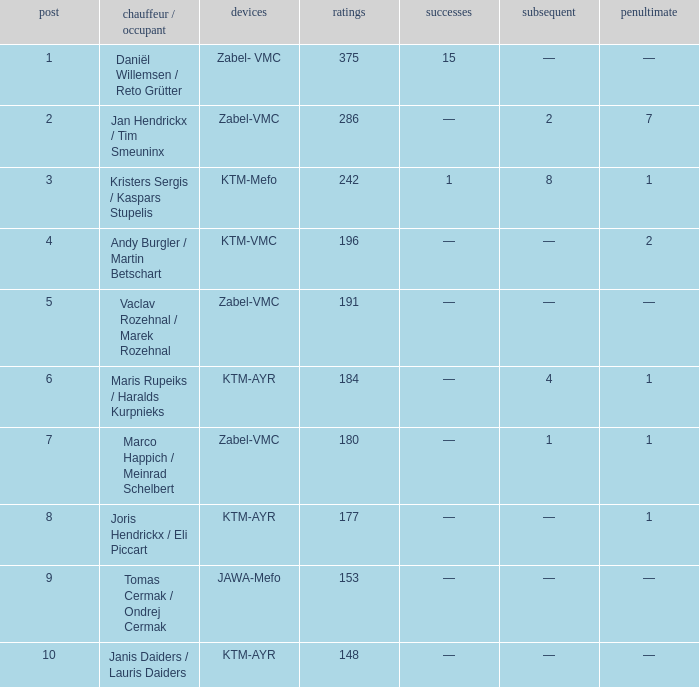What was the maximum points when the second was 4? 184.0. 